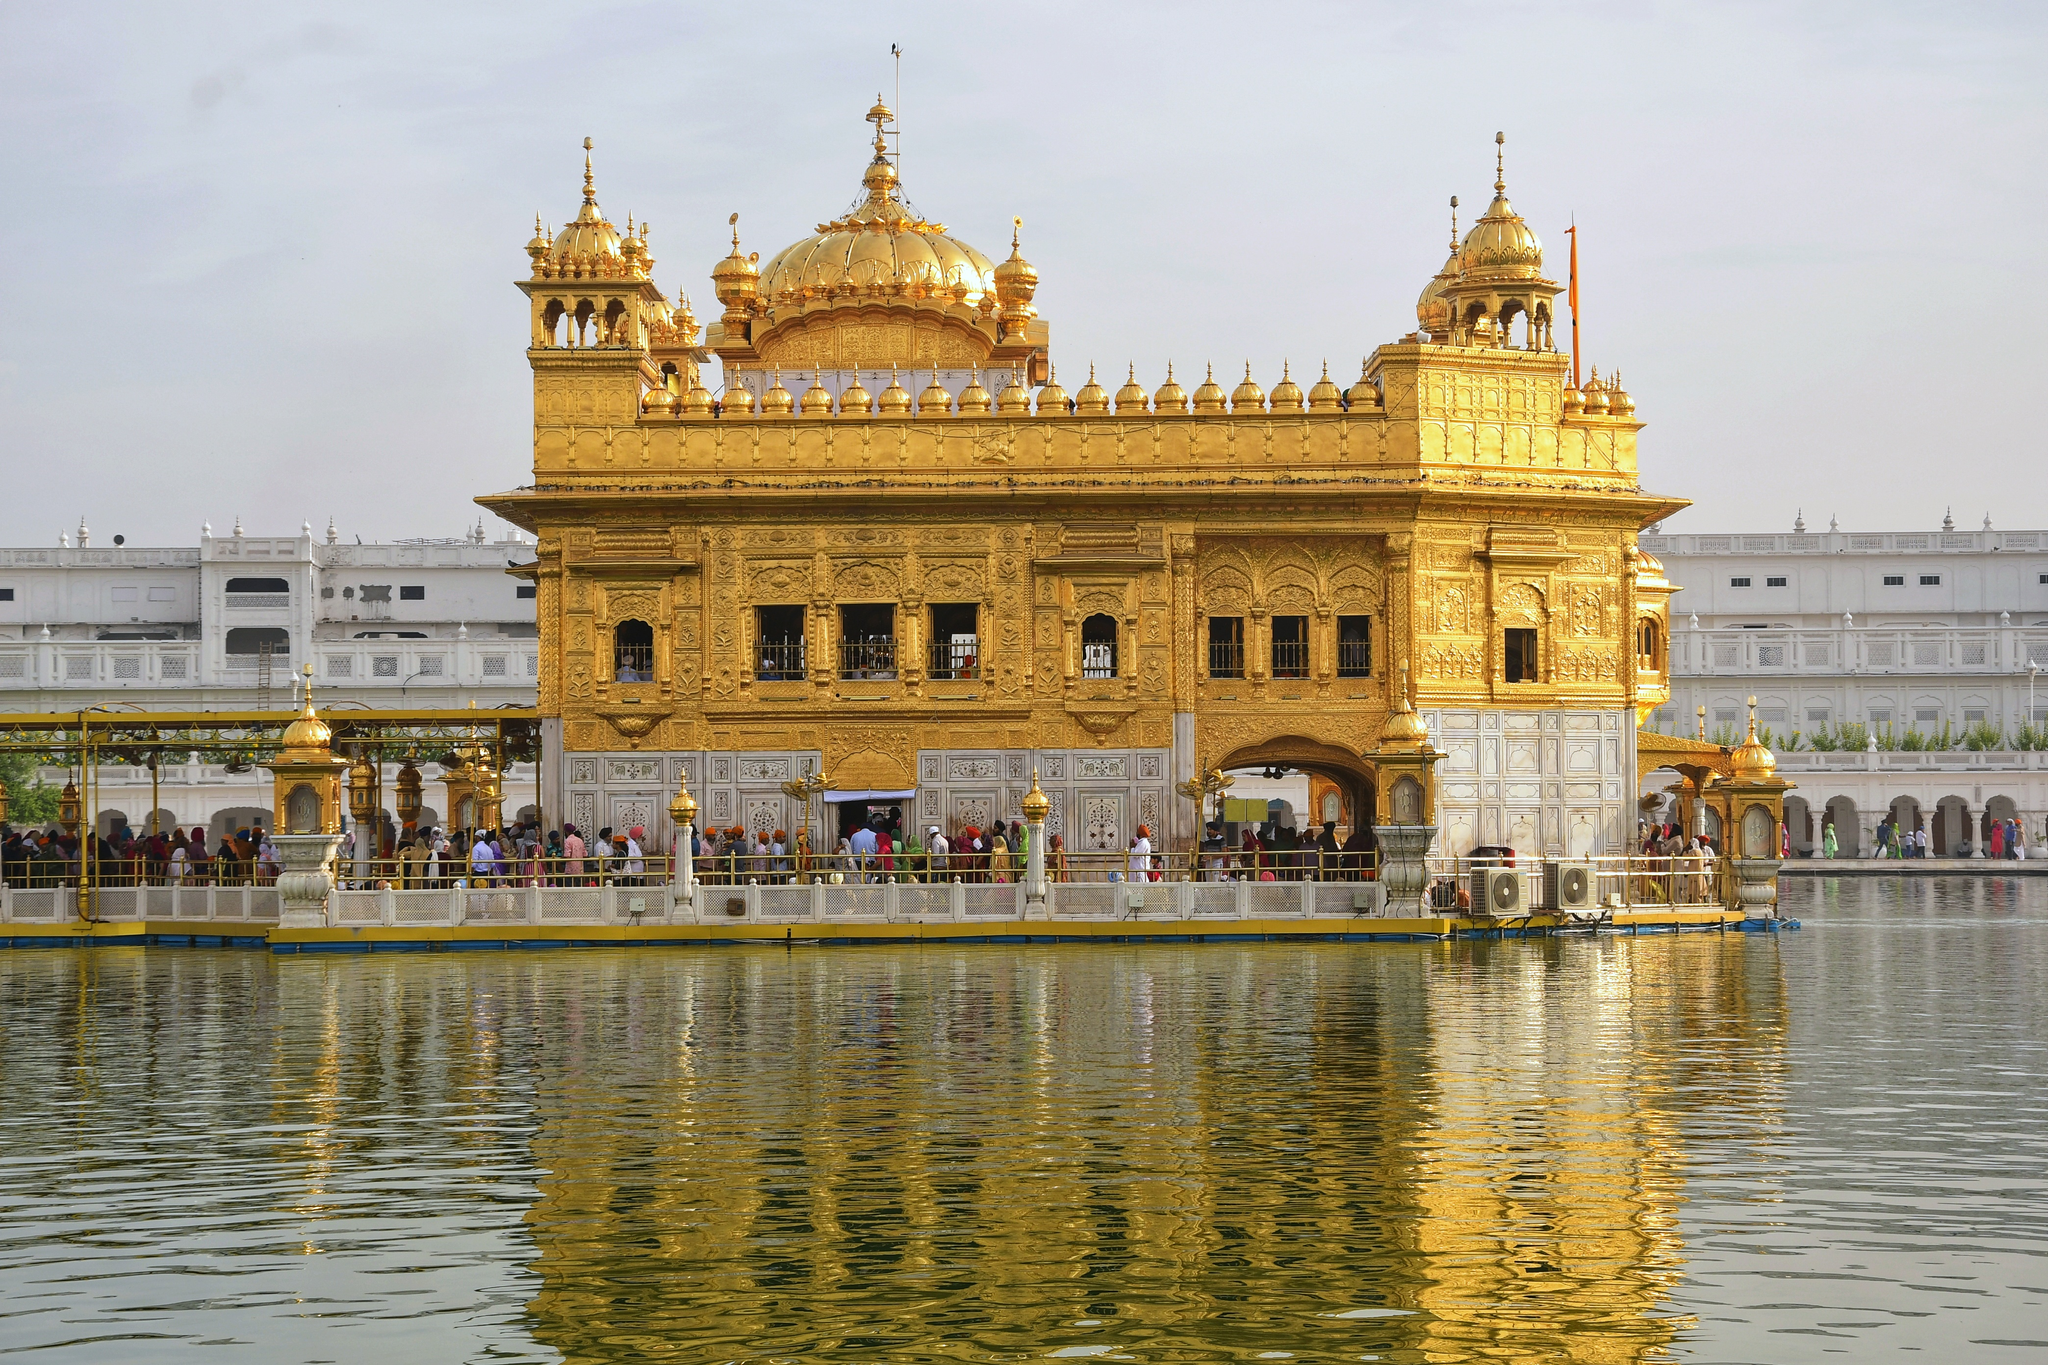What do you think is going on in this snapshot? This image beautifully captures the Golden Temple, also known as Harmandir Sahib, located in Amritsar, India. It's a pivotal spiritual and cultural center for the Sikh religion. The temple's exquisite golden facade and intricate architecture reflect early morning or late afternoon light, enhancing its ornate details and the serene waters surrounding it. The temple stands amidst a large, holy water body known as the Amrit Sarovar, from which the city derives its name. Devotees from various parts of the world visit this sacred site for prayer and reflection, as evidenced by the diverse group of people seen walking around the marble walkway. This scene is not just a daily occurrence but a profound illustration of devotion and peace, central to Sikhism. 